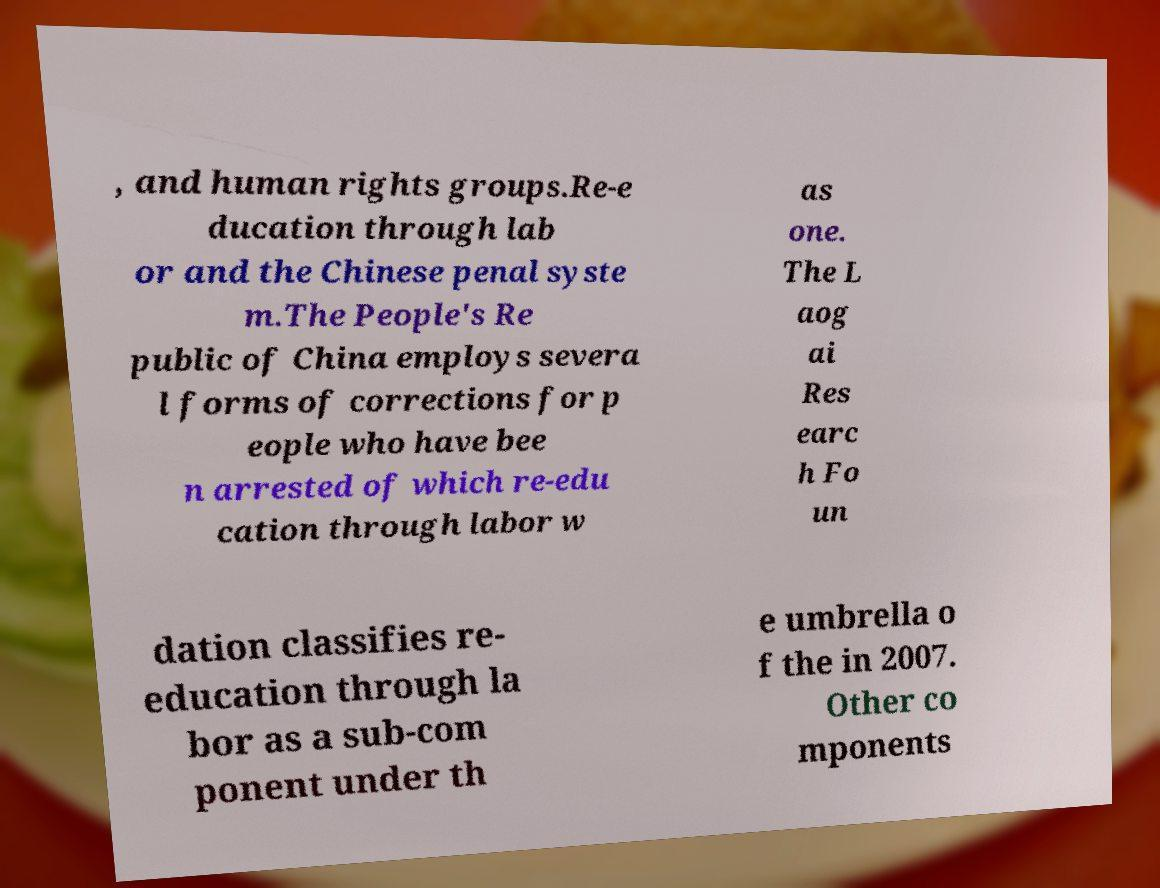Please read and relay the text visible in this image. What does it say? , and human rights groups.Re-e ducation through lab or and the Chinese penal syste m.The People's Re public of China employs severa l forms of corrections for p eople who have bee n arrested of which re-edu cation through labor w as one. The L aog ai Res earc h Fo un dation classifies re- education through la bor as a sub-com ponent under th e umbrella o f the in 2007. Other co mponents 